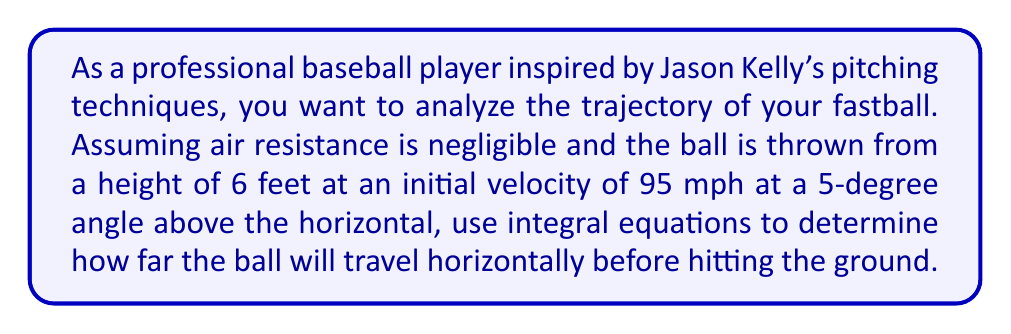Could you help me with this problem? Let's approach this step-by-step using integral equations:

1) First, we need to break down the initial velocity into its horizontal and vertical components:
   $v_{x0} = 95 \cos(5°) \approx 94.63$ mph
   $v_{y0} = 95 \sin(5°) \approx 8.28$ mph

2) Convert the velocities to ft/s:
   $v_{x0} \approx 138.79$ ft/s
   $v_{y0} \approx 12.14$ ft/s

3) The horizontal velocity remains constant (neglecting air resistance):
   $v_x(t) = v_{x0} = 138.79$ ft/s

4) The vertical velocity changes due to gravity:
   $v_y(t) = v_{y0} - gt$, where $g = 32.2$ ft/s²

5) To find the position, we integrate the velocity:
   $x(t) = \int v_x(t) dt = 138.79t + C_1$
   $y(t) = \int v_y(t) dt = 12.14t - 16.1t^2 + C_2$

6) Using initial conditions ($x(0) = 0$, $y(0) = 6$), we get:
   $x(t) = 138.79t$
   $y(t) = 6 + 12.14t - 16.1t^2$

7) The ball hits the ground when $y(t) = 0$. Solve this quadratic equation:
   $6 + 12.14t - 16.1t^2 = 0$
   $16.1t^2 - 12.14t - 6 = 0$

8) Using the quadratic formula, we get:
   $t \approx 0.8927$ seconds (positive root)

9) Substitute this time into the $x(t)$ equation:
   $x(0.8927) = 138.79 * 0.8927 \approx 123.90$ ft

Therefore, the ball will travel approximately 123.90 feet horizontally before hitting the ground.
Answer: 123.90 feet 